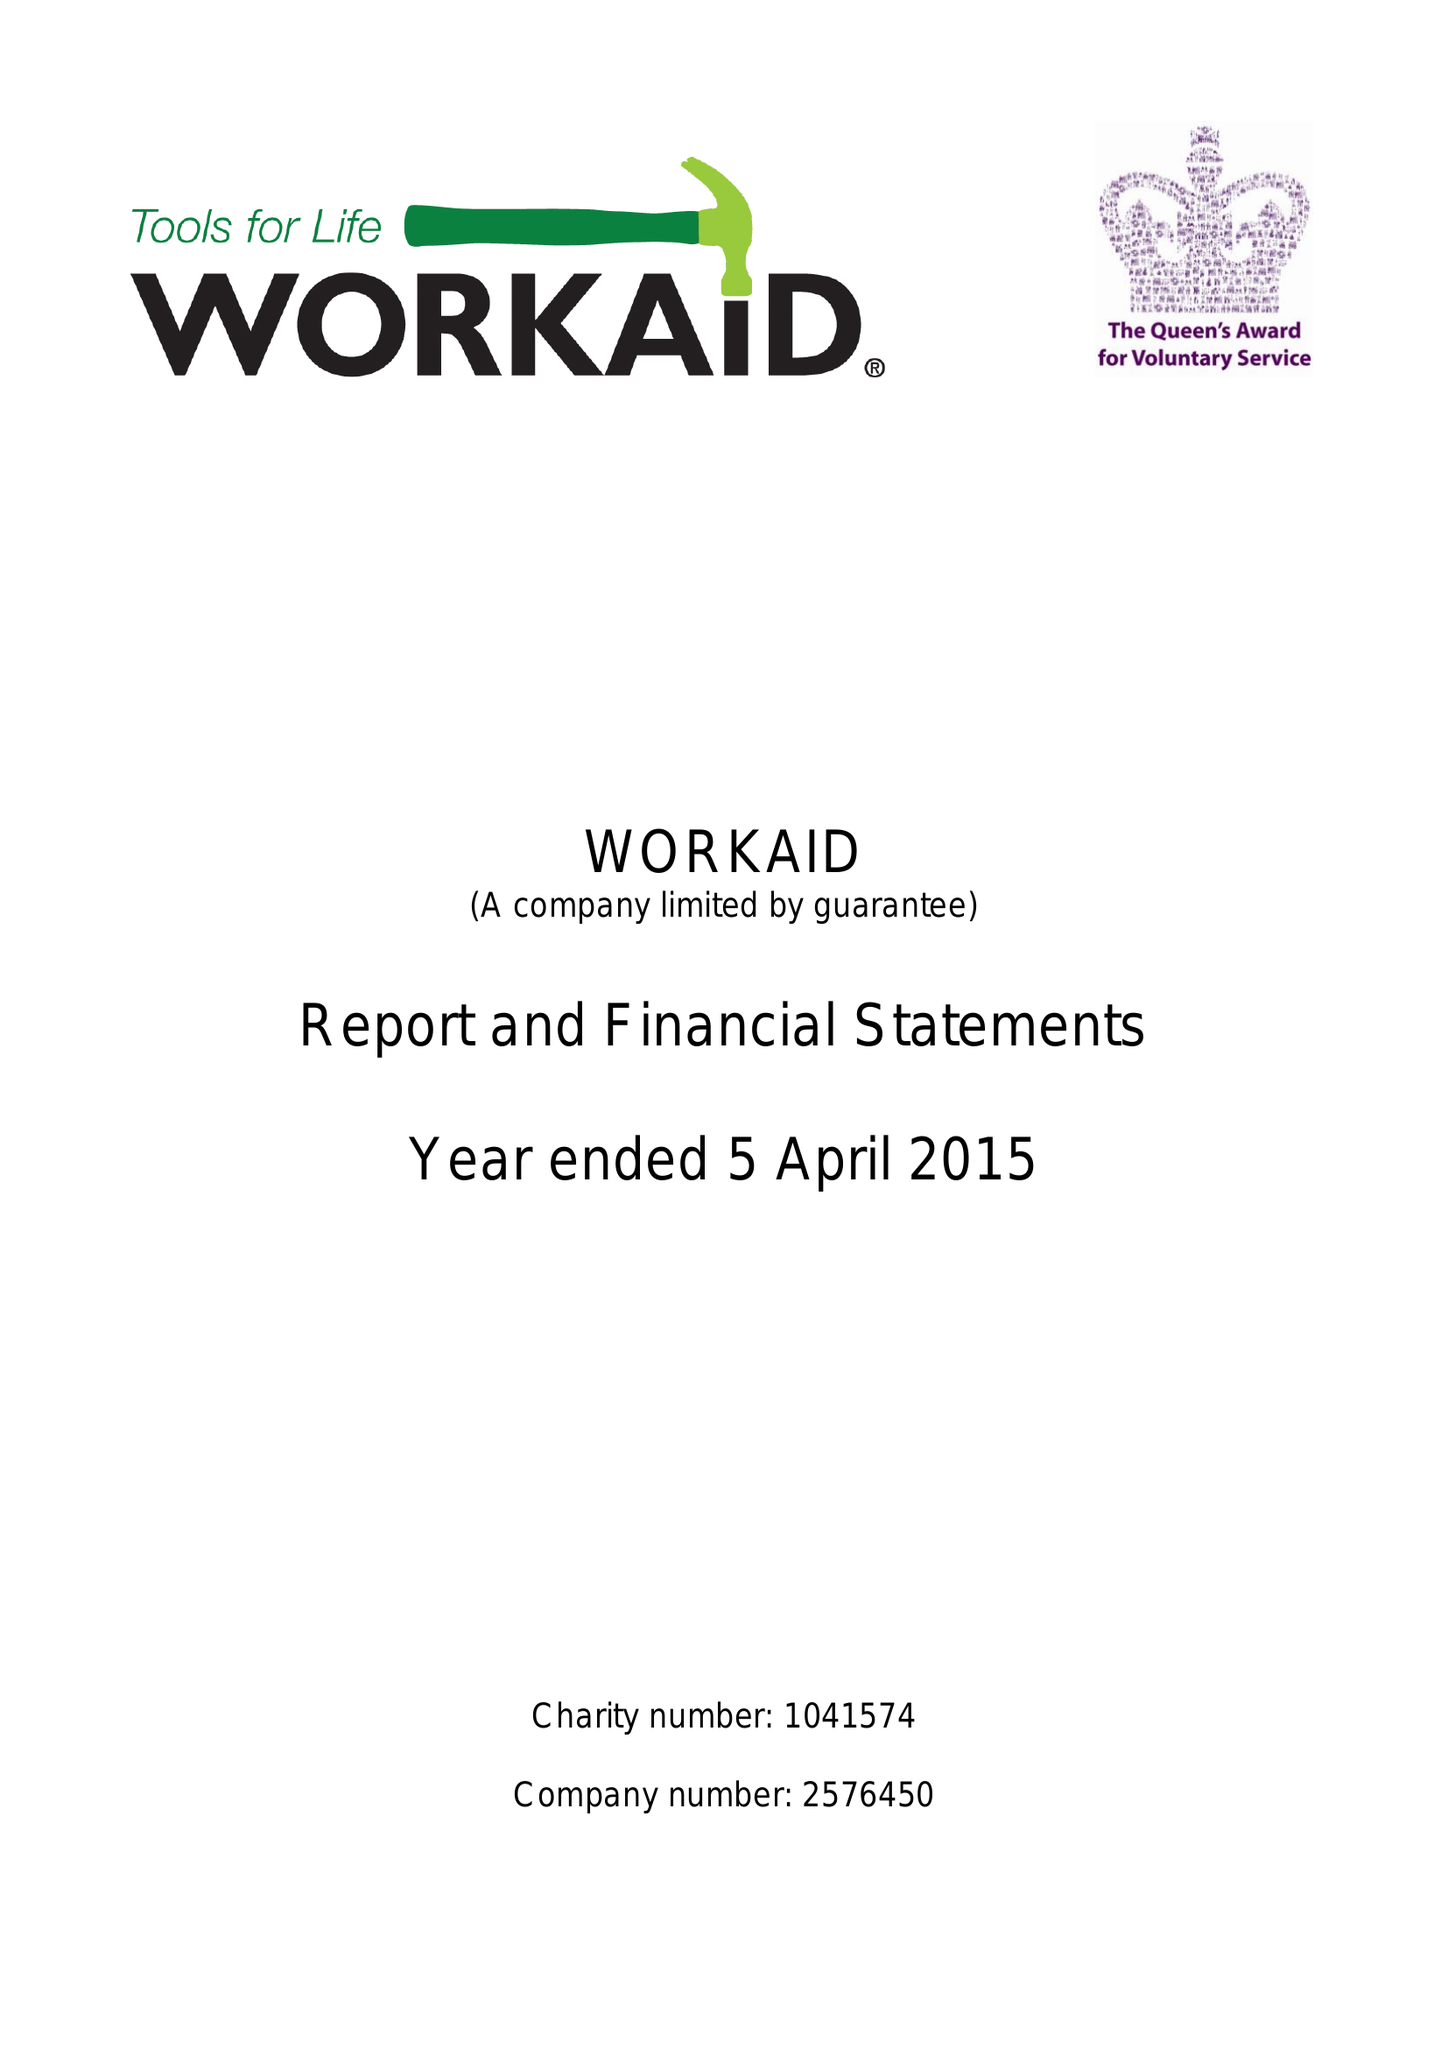What is the value for the report_date?
Answer the question using a single word or phrase. 2015-04-05 